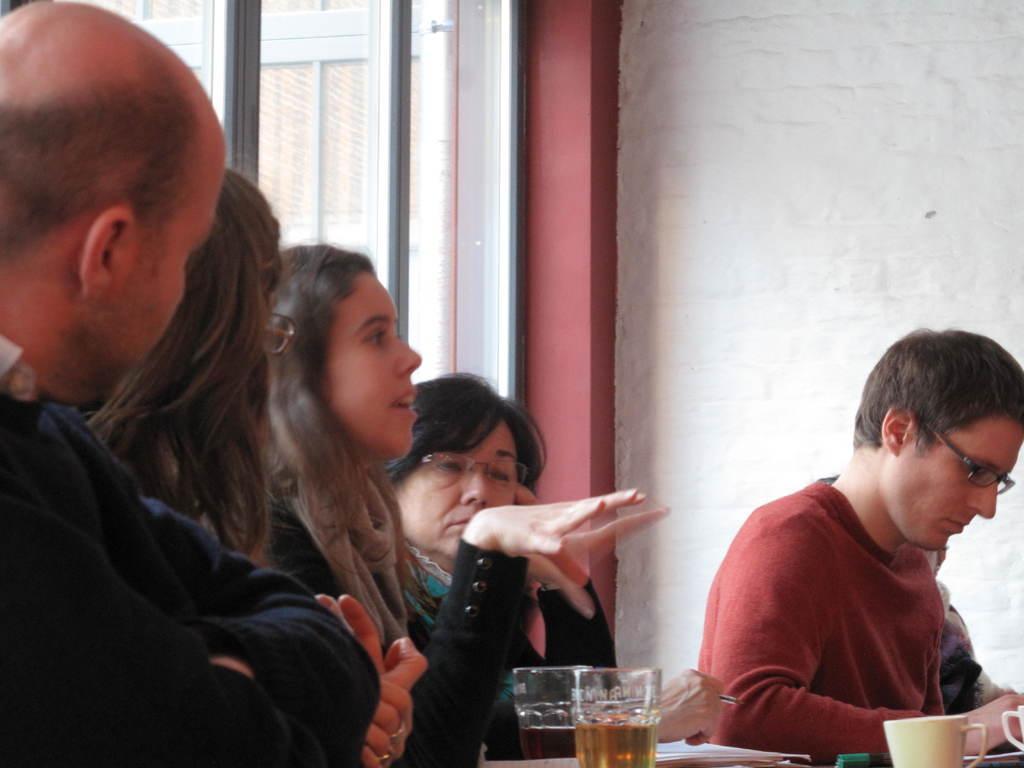Can you describe this image briefly? In the image we can see there are people wearing clothes and some of them are wearing spectacles. Here we can see two glasses with liquid in it, tea cup and papers. Here we can see the wall and a glass window. 